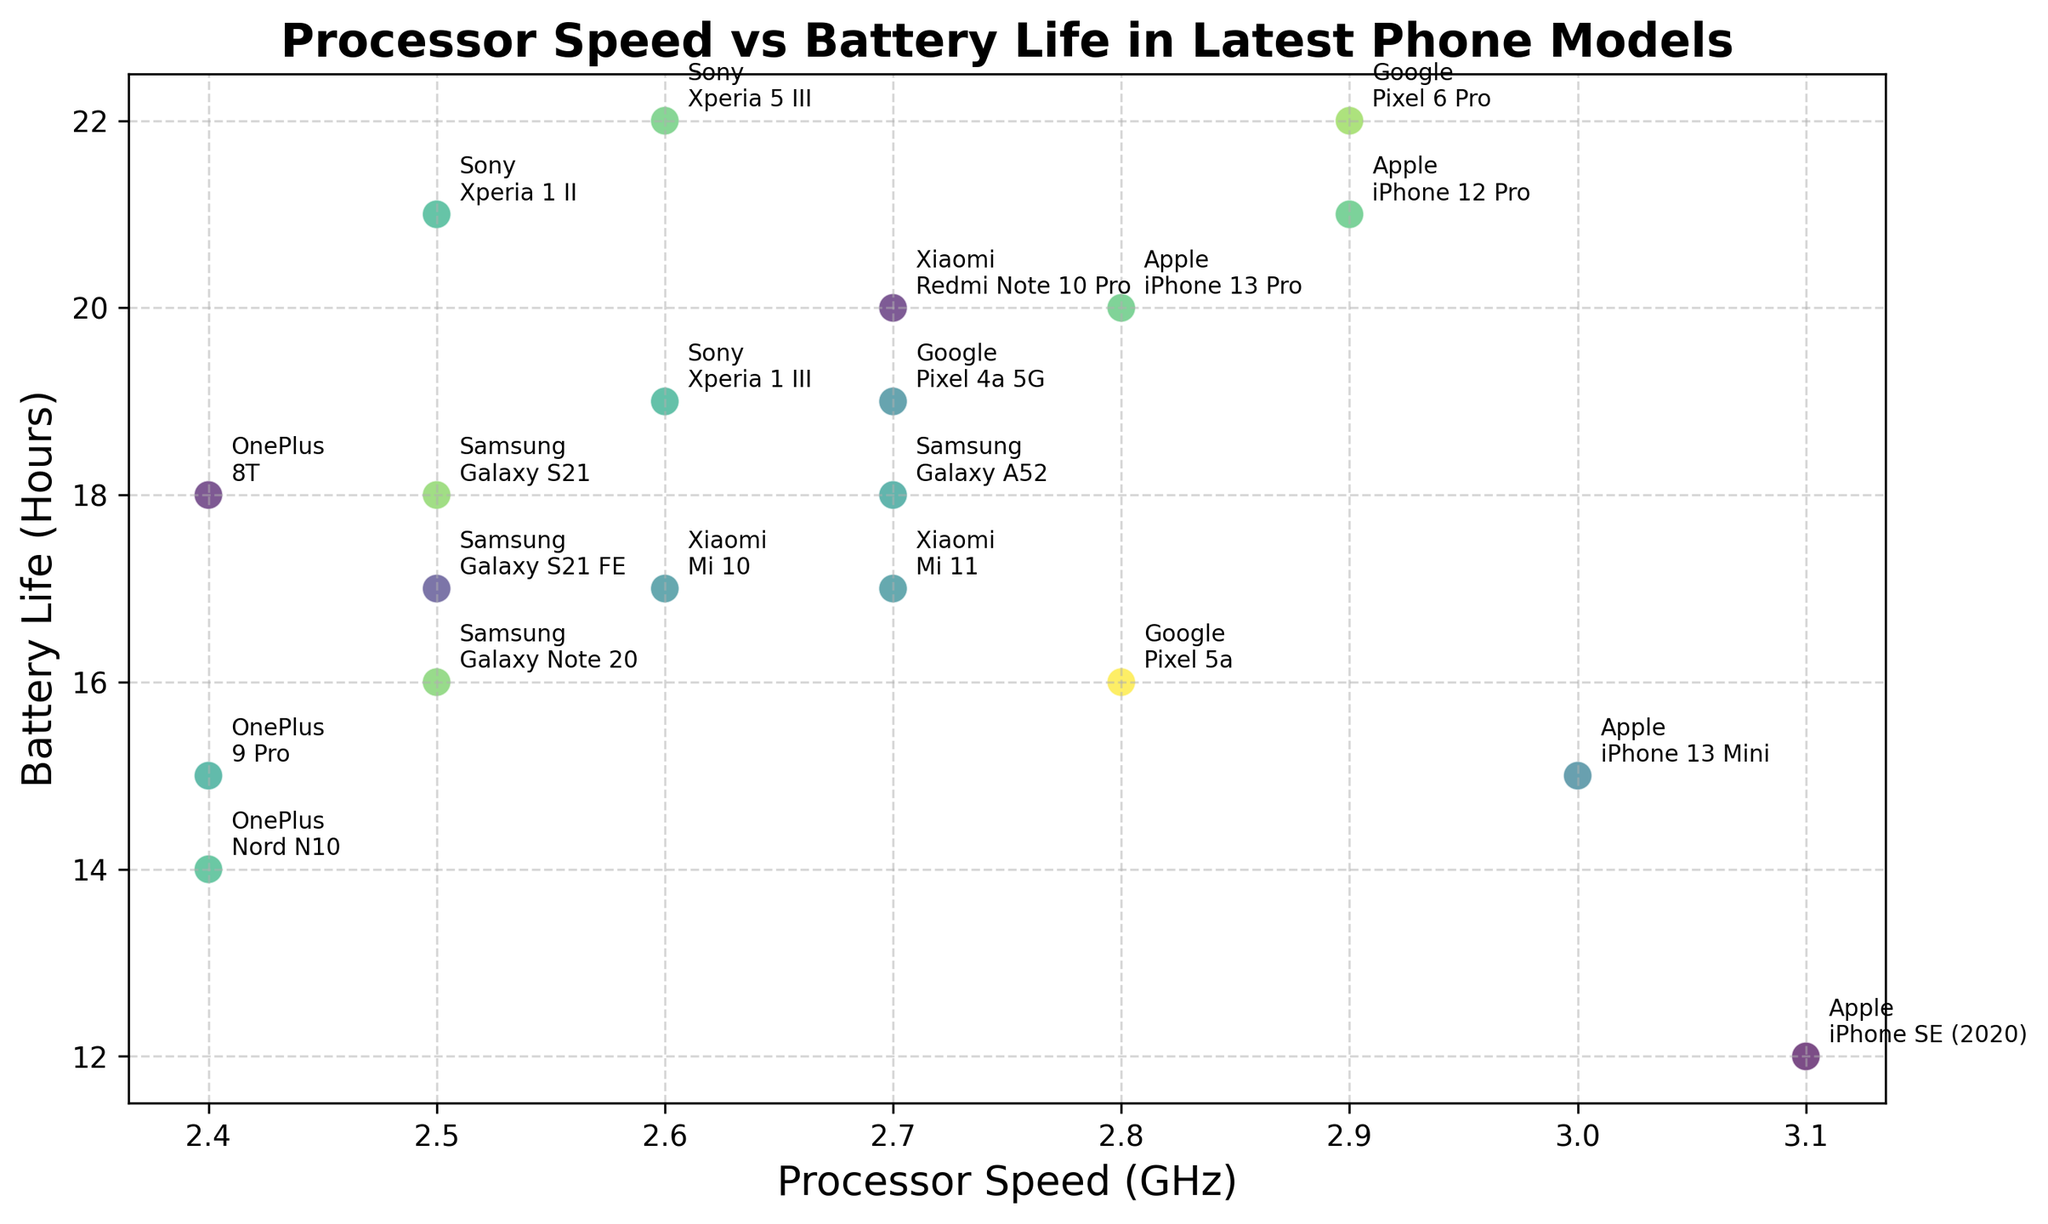What's the phone model with the highest processor speed? The highest processor speed is 3.1 GHz, which corresponds to the "iPhone SE (2020)" model.
Answer: iPhone SE (2020) Which manufacturer has the phone model with the longest battery life? The phone model with the longest battery life is "Xperia 5 III" by Sony, offering 22 hours.
Answer: Sony Compare the battery life of the "iPhone 13 Pro" to the "Galaxy S21 FE". Which one lasts longer? The "iPhone 13 Pro" has a battery life of 20 hours, while the "Galaxy S21 FE" has 17 hours. Therefore, "iPhone 13 Pro" lasts longer.
Answer: iPhone 13 Pro Which phone models have a processor speed of 2.7 GHz? The phone models with a processor speed of 2.7 GHz are "Mi 11", "Redmi Note 10 Pro", "Galaxy A52", and "Pixel 4a 5G".
Answer: Mi 11, Redmi Note 10 Pro, Galaxy A52, Pixel 4a 5G What is the average battery life of all Apple models in the plot? Apple models' battery life: 20 (iPhone 13 Pro), 15 (iPhone 13 Mini), 21 (iPhone 12 Pro), 12 (iPhone SE). Average is (20 + 15 + 21 + 12) / 4 = 17
Answer: 17 Is there any phone model with both processor speed >= 3 GHz and battery life >= 20 hours? No phone model satisfies both conditions of having processor speed >= 3 GHz and battery life >= 20 hours.
Answer: No Among the phone models by Samsung, which one has the highest battery life and what is it? The "Galaxy S21" by Samsung has the highest battery life of 18 hours among Samsung models.
Answer: Galaxy S21 How many phone models have a battery life greater than 20 hours? The phone models with battery life greater than 20 hours are "Pixel 6 Pro", "Xperia 5 III", and "Xperia 1 II". A total of 3 models.
Answer: 3 Which phone model by Google has the lowest battery life? The "Pixel 5a" by Google has the lowest battery life of 16 hours.
Answer: Pixel 5a Is there a notable difference in battery life between the "OnePlus 9 Pro" and "OnePlus Nord N10"? If so, what is it? The "OnePlus 9 Pro" has a battery life of 15 hours, while the "Nord N10" has 14 hours. The difference is 1 hour.
Answer: 1 hour 